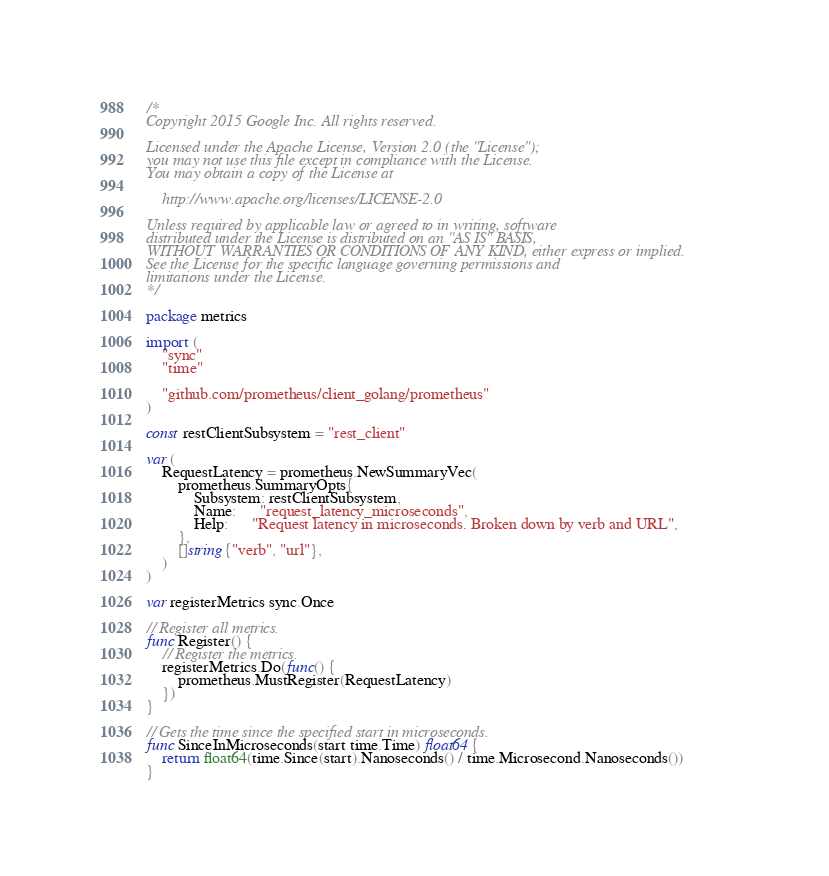<code> <loc_0><loc_0><loc_500><loc_500><_Go_>/*
Copyright 2015 Google Inc. All rights reserved.

Licensed under the Apache License, Version 2.0 (the "License");
you may not use this file except in compliance with the License.
You may obtain a copy of the License at

    http://www.apache.org/licenses/LICENSE-2.0

Unless required by applicable law or agreed to in writing, software
distributed under the License is distributed on an "AS IS" BASIS,
WITHOUT WARRANTIES OR CONDITIONS OF ANY KIND, either express or implied.
See the License for the specific language governing permissions and
limitations under the License.
*/

package metrics

import (
	"sync"
	"time"

	"github.com/prometheus/client_golang/prometheus"
)

const restClientSubsystem = "rest_client"

var (
	RequestLatency = prometheus.NewSummaryVec(
		prometheus.SummaryOpts{
			Subsystem: restClientSubsystem,
			Name:      "request_latency_microseconds",
			Help:      "Request latency in microseconds. Broken down by verb and URL",
		},
		[]string{"verb", "url"},
	)
)

var registerMetrics sync.Once

// Register all metrics.
func Register() {
	// Register the metrics.
	registerMetrics.Do(func() {
		prometheus.MustRegister(RequestLatency)
	})
}

// Gets the time since the specified start in microseconds.
func SinceInMicroseconds(start time.Time) float64 {
	return float64(time.Since(start).Nanoseconds() / time.Microsecond.Nanoseconds())
}
</code> 